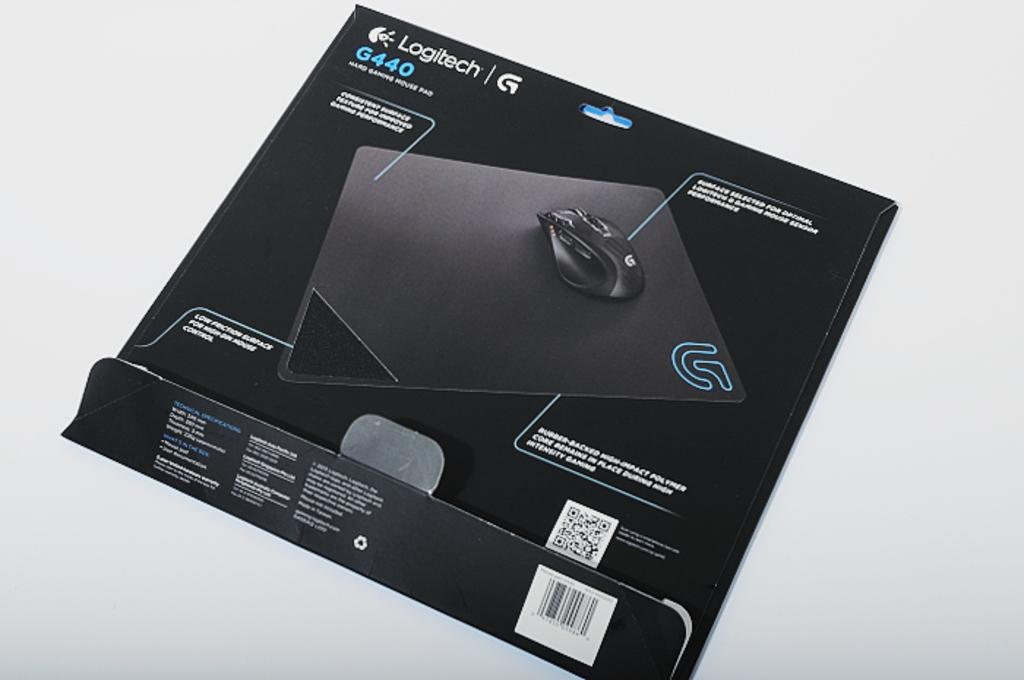What is the main object in the image? There is a paper cover in the image. What is depicted on the paper cover? The paper cover has a picture of a mouse. Are there any words or letters on the paper cover? Yes, there is text on the paper cover. What color is the background of the image? The background of the image is white. How many tickets are visible in the image? There are no tickets present in the image. What is the taste of the mouse depicted on the paper cover? The image does not provide any information about the taste of the mouse, as it is a picture on a paper cover. 